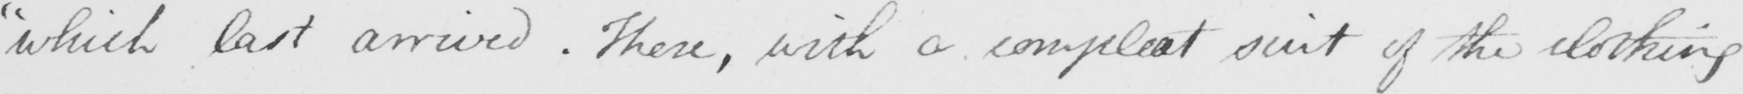Transcribe the text shown in this historical manuscript line. " which last arrived . These , with a compleat suit of the clothing 